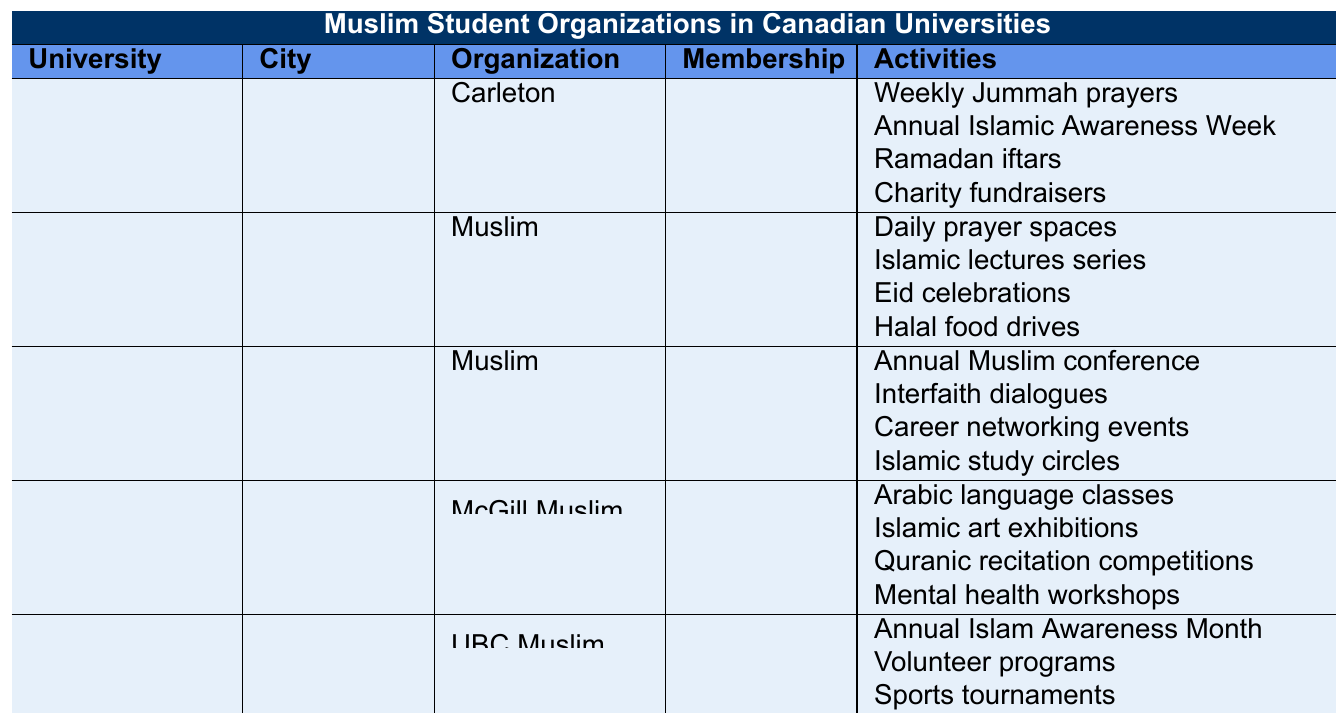How many Muslim student organizations are listed in the table? The table shows five universities, each with one Muslim student organization listed, so the total is 5 organizations.
Answer: 5 What is the membership of the Muslim Students Association at the University of Toronto? The table indicates that the membership of the Muslim Students' Association at the University of Toronto is 1200.
Answer: 1200 Which university has the highest Muslim student organization membership? When comparing the membership values, the University of Toronto has the highest membership at 1200.
Answer: University of Toronto Are there any universities located in Ottawa, and if so, how many? The table lists Carleton University and the University of Ottawa, both located in Ottawa, so there are 2 universities in Ottawa.
Answer: 2 What are the activities offered by the UBC Muslim Students Association? The table lists the activities as: Annual Islam Awareness Month, Volunteer programs, Sports tournaments, and Islamic finance seminars.
Answer: Annual Islam Awareness Month, Volunteer programs, Sports tournaments, Islamic finance seminars Which university's organization focuses on mental health workshops? The table indicates that the McGill Muslim Students Association offers mental health workshops among its activities.
Answer: McGill University What is the average membership of Muslim student organizations across the listed universities? The total membership is 450 + 600 + 1200 + 800 + 950 = 4000. Since there are 5 organizations, the average membership is 4000 / 5 = 800.
Answer: 800 Is it true that the Muslim Students Association at the University of Ottawa conducts Halal food drives? The table states that the Muslim Students Association at the University of Ottawa does indeed conduct Halal food drives as one of their activities.
Answer: Yes Which university has the fewest activities for its Muslim organization? Carleton University’s Muslim Students' Association has four activities, while McGill and the others also have four. However, they are all tied with four.
Answer: None; all have four activities How many activities focus explicitly on charity or community assistance? The organizations at Carleton (charity fundraisers), University of Ottawa (Halal food drives), and UBC (volunteer programs) have activities related to charity or community assistance. That gives us 3 activities focusing on charity or community assistance.
Answer: 3 